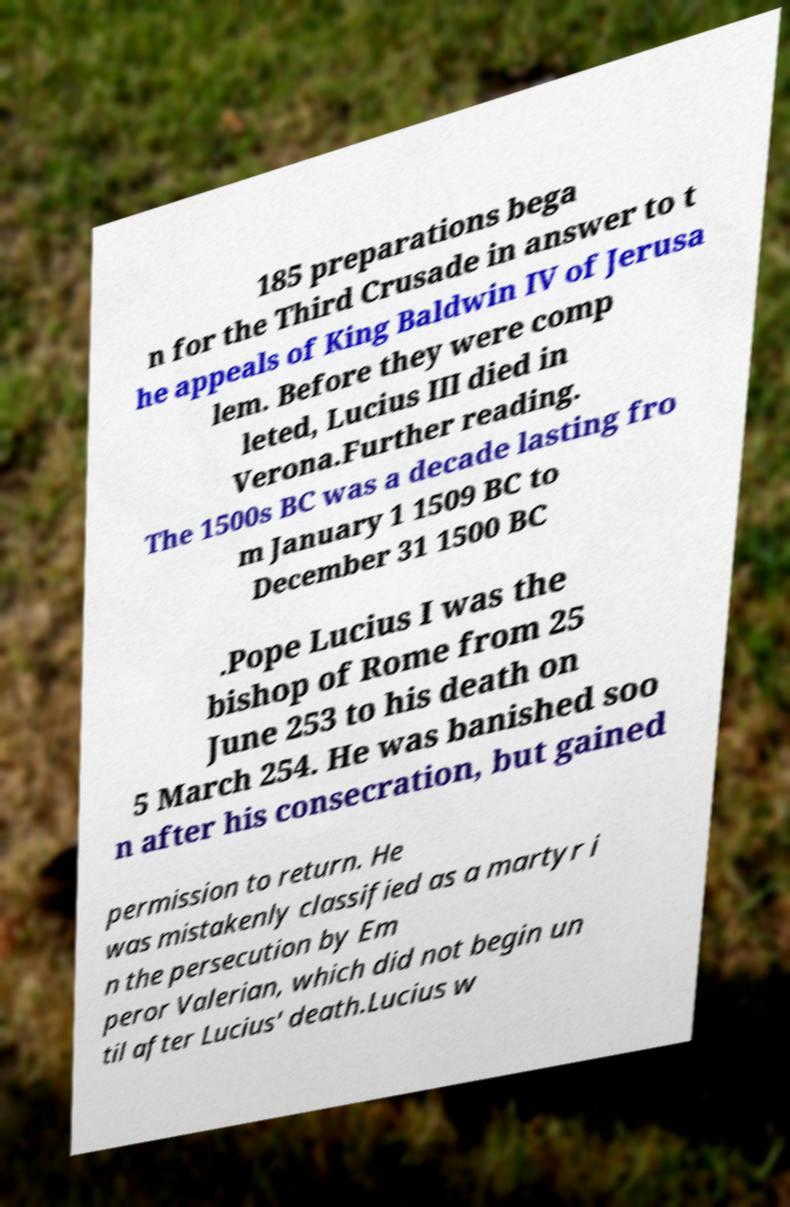Please read and relay the text visible in this image. What does it say? 185 preparations bega n for the Third Crusade in answer to t he appeals of King Baldwin IV of Jerusa lem. Before they were comp leted, Lucius III died in Verona.Further reading. The 1500s BC was a decade lasting fro m January 1 1509 BC to December 31 1500 BC .Pope Lucius I was the bishop of Rome from 25 June 253 to his death on 5 March 254. He was banished soo n after his consecration, but gained permission to return. He was mistakenly classified as a martyr i n the persecution by Em peror Valerian, which did not begin un til after Lucius' death.Lucius w 